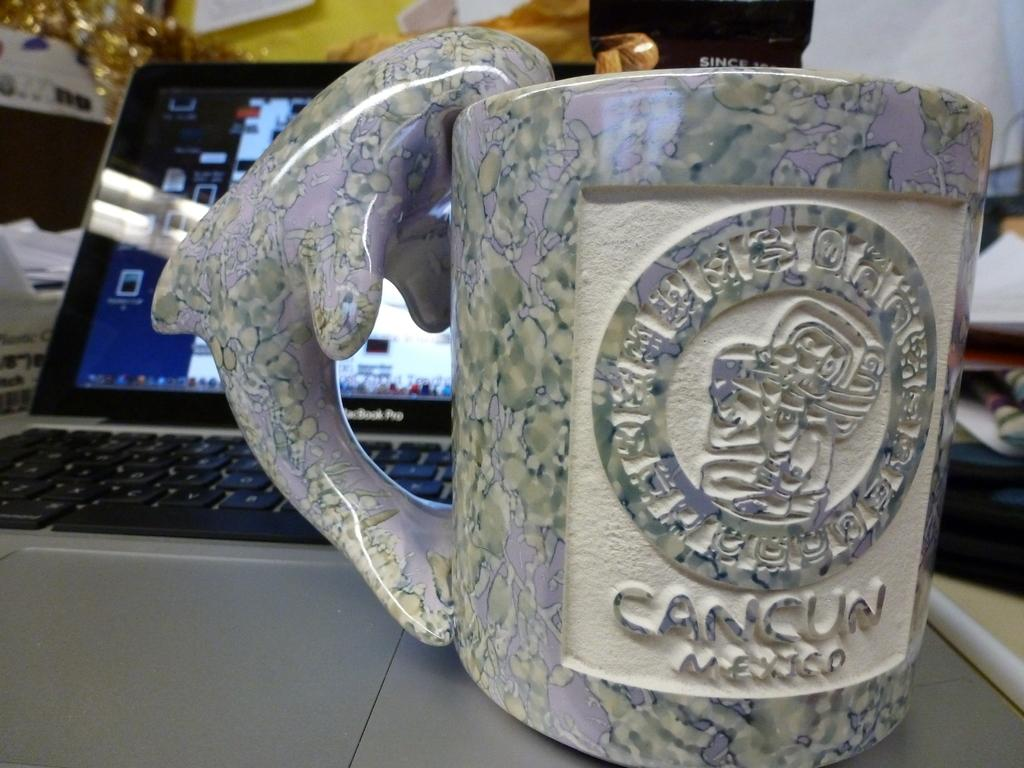<image>
Render a clear and concise summary of the photo. A stone coffee cup with Cancun Mexico carved into it. 